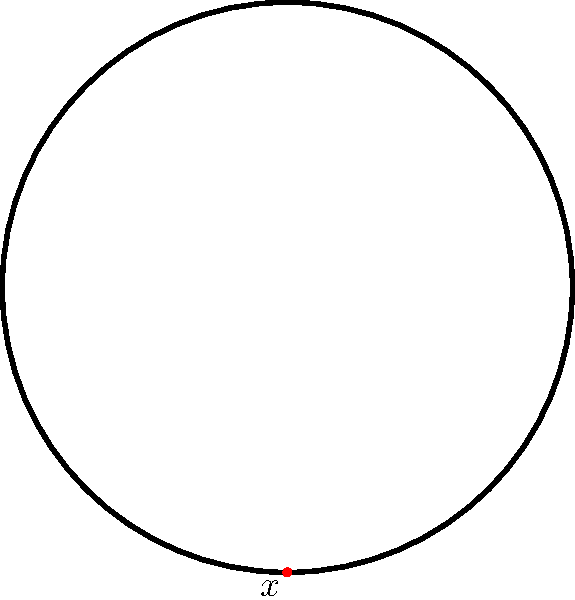Given the simple knot diagram above, identify the fundamental group of the knot complement. How does this relate to the concept of knot invariants in topology? To determine the fundamental group of the knot complement, we follow these steps:

1. Observe that the given diagram represents a trefoil knot.

2. For any knot $K$, the fundamental group of its complement, denoted $\pi_1(S^3 \setminus K)$, is a knot invariant.

3. For the trefoil knot, the fundamental group is known to be:

   $$\pi_1(S^3 \setminus K) = \langle a, b \mid aba = bab \rangle$$

   This is called the knot group of the trefoil.

4. This group can be interpreted as having two generators ($a$ and $b$) with one relation ($aba = bab$).

5. The fundamental group is a powerful knot invariant because:
   a) It is independent of the specific diagram used to represent the knot.
   b) It can distinguish between many different knots.
   c) If two knots have different fundamental groups, they are not equivalent.

6. In the context of education and tutoring, understanding fundamental groups provides insight into more advanced topological concepts and can help students grasp abstract mathematical ideas.
Answer: $\langle a, b \mid aba = bab \rangle$ 